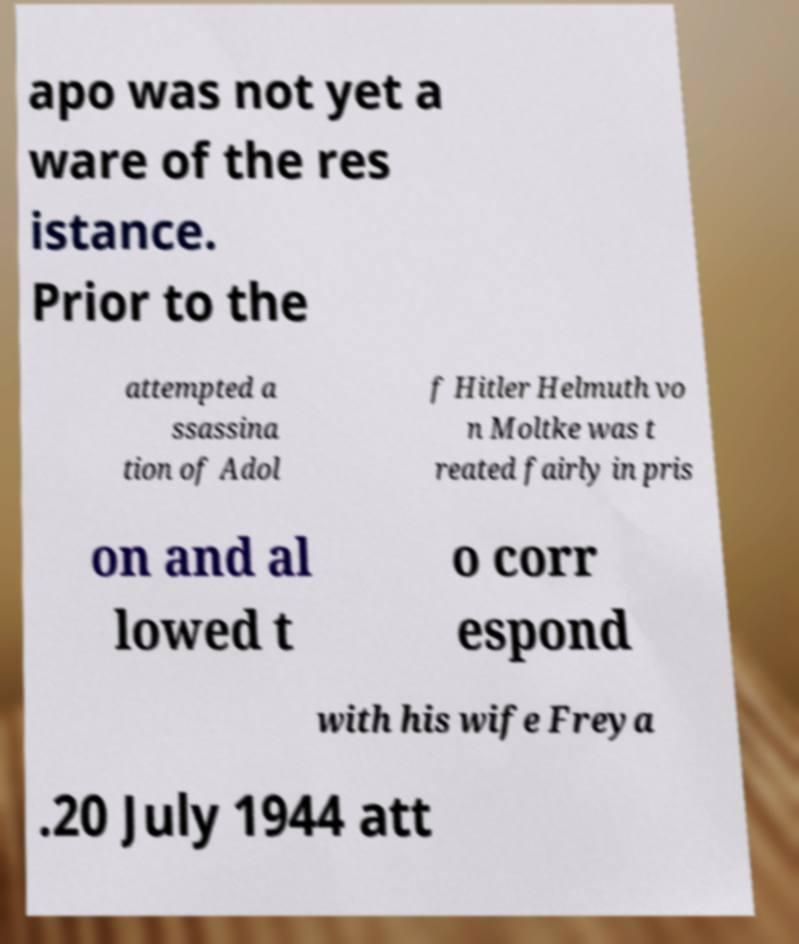Can you accurately transcribe the text from the provided image for me? apo was not yet a ware of the res istance. Prior to the attempted a ssassina tion of Adol f Hitler Helmuth vo n Moltke was t reated fairly in pris on and al lowed t o corr espond with his wife Freya .20 July 1944 att 